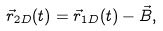<formula> <loc_0><loc_0><loc_500><loc_500>\vec { r } _ { 2 D } ( t ) = \vec { r } _ { 1 D } ( t ) - \vec { B } ,</formula> 